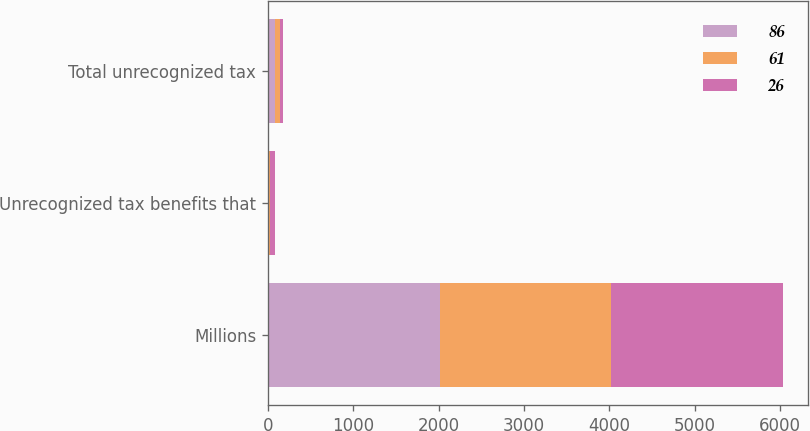<chart> <loc_0><loc_0><loc_500><loc_500><stacked_bar_chart><ecel><fcel>Millions<fcel>Unrecognized tax benefits that<fcel>Total unrecognized tax<nl><fcel>86<fcel>2010<fcel>4<fcel>86<nl><fcel>61<fcel>2009<fcel>25<fcel>61<nl><fcel>26<fcel>2008<fcel>53<fcel>26<nl></chart> 